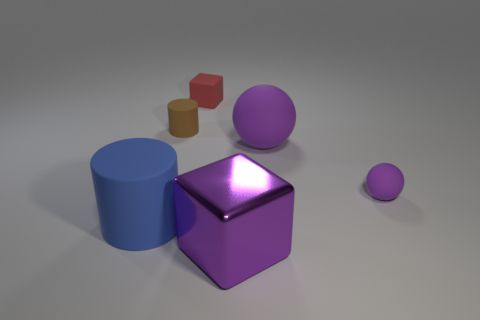Subtract 1 cylinders. How many cylinders are left? 1 Subtract all gray cylinders. Subtract all purple blocks. How many cylinders are left? 2 Subtract all cyan cubes. How many blue cylinders are left? 1 Subtract all tiny brown objects. Subtract all tiny red rubber objects. How many objects are left? 4 Add 1 big purple matte things. How many big purple matte things are left? 2 Add 5 brown rubber things. How many brown rubber things exist? 6 Add 2 big cyan metal things. How many objects exist? 8 Subtract all blue cylinders. How many cylinders are left? 1 Subtract 0 green spheres. How many objects are left? 6 Subtract all cylinders. How many objects are left? 4 